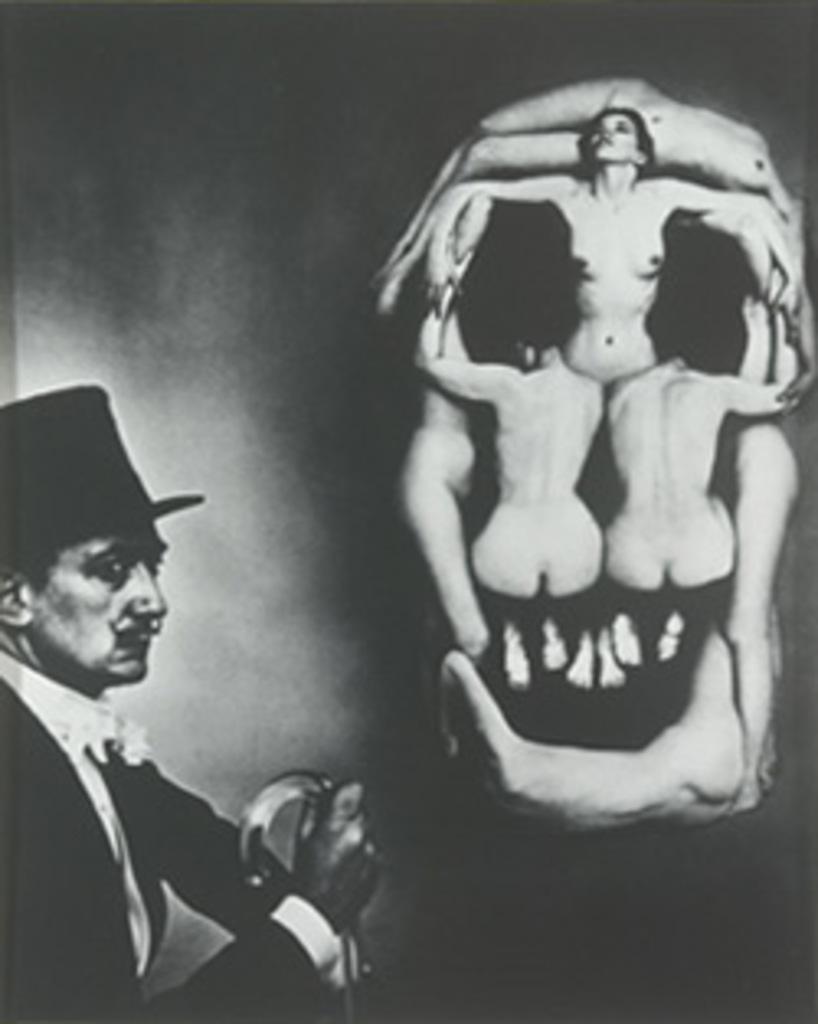How would you summarize this image in a sentence or two? It is a black and white picture. On the left side of the image, we can see one person is holding some object and he is wearing a hat. On the right side of the image, we can see a few people. And we can see the dark background. 